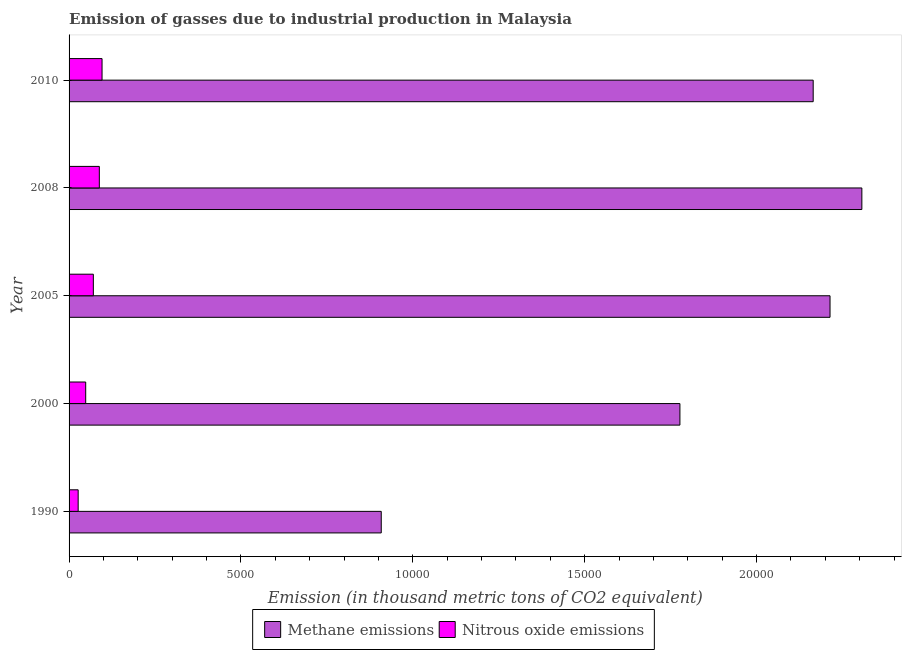How many different coloured bars are there?
Offer a terse response. 2. How many groups of bars are there?
Keep it short and to the point. 5. Are the number of bars per tick equal to the number of legend labels?
Provide a succinct answer. Yes. Are the number of bars on each tick of the Y-axis equal?
Offer a terse response. Yes. What is the label of the 2nd group of bars from the top?
Your response must be concise. 2008. In how many cases, is the number of bars for a given year not equal to the number of legend labels?
Keep it short and to the point. 0. What is the amount of methane emissions in 2000?
Give a very brief answer. 1.78e+04. Across all years, what is the maximum amount of methane emissions?
Offer a very short reply. 2.31e+04. Across all years, what is the minimum amount of nitrous oxide emissions?
Offer a terse response. 264.6. What is the total amount of nitrous oxide emissions in the graph?
Offer a terse response. 3294. What is the difference between the amount of methane emissions in 1990 and that in 2010?
Your answer should be very brief. -1.26e+04. What is the difference between the amount of methane emissions in 2005 and the amount of nitrous oxide emissions in 2010?
Make the answer very short. 2.12e+04. What is the average amount of nitrous oxide emissions per year?
Make the answer very short. 658.8. In the year 2000, what is the difference between the amount of nitrous oxide emissions and amount of methane emissions?
Keep it short and to the point. -1.73e+04. What is the ratio of the amount of nitrous oxide emissions in 2000 to that in 2010?
Your response must be concise. 0.5. Is the difference between the amount of methane emissions in 2005 and 2008 greater than the difference between the amount of nitrous oxide emissions in 2005 and 2008?
Give a very brief answer. No. What is the difference between the highest and the second highest amount of nitrous oxide emissions?
Your answer should be compact. 78.9. What is the difference between the highest and the lowest amount of methane emissions?
Your answer should be very brief. 1.40e+04. What does the 2nd bar from the top in 2008 represents?
Provide a succinct answer. Methane emissions. What does the 2nd bar from the bottom in 2000 represents?
Offer a terse response. Nitrous oxide emissions. How many bars are there?
Make the answer very short. 10. Are all the bars in the graph horizontal?
Offer a very short reply. Yes. Are the values on the major ticks of X-axis written in scientific E-notation?
Your answer should be very brief. No. Does the graph contain any zero values?
Your answer should be very brief. No. What is the title of the graph?
Make the answer very short. Emission of gasses due to industrial production in Malaysia. What is the label or title of the X-axis?
Offer a terse response. Emission (in thousand metric tons of CO2 equivalent). What is the Emission (in thousand metric tons of CO2 equivalent) in Methane emissions in 1990?
Make the answer very short. 9082.4. What is the Emission (in thousand metric tons of CO2 equivalent) in Nitrous oxide emissions in 1990?
Provide a succinct answer. 264.6. What is the Emission (in thousand metric tons of CO2 equivalent) of Methane emissions in 2000?
Provide a short and direct response. 1.78e+04. What is the Emission (in thousand metric tons of CO2 equivalent) of Nitrous oxide emissions in 2000?
Provide a short and direct response. 483.7. What is the Emission (in thousand metric tons of CO2 equivalent) of Methane emissions in 2005?
Provide a succinct answer. 2.21e+04. What is the Emission (in thousand metric tons of CO2 equivalent) in Nitrous oxide emissions in 2005?
Your response must be concise. 706. What is the Emission (in thousand metric tons of CO2 equivalent) of Methane emissions in 2008?
Offer a very short reply. 2.31e+04. What is the Emission (in thousand metric tons of CO2 equivalent) of Nitrous oxide emissions in 2008?
Your answer should be compact. 880.4. What is the Emission (in thousand metric tons of CO2 equivalent) of Methane emissions in 2010?
Give a very brief answer. 2.16e+04. What is the Emission (in thousand metric tons of CO2 equivalent) in Nitrous oxide emissions in 2010?
Your answer should be very brief. 959.3. Across all years, what is the maximum Emission (in thousand metric tons of CO2 equivalent) in Methane emissions?
Offer a very short reply. 2.31e+04. Across all years, what is the maximum Emission (in thousand metric tons of CO2 equivalent) in Nitrous oxide emissions?
Your answer should be compact. 959.3. Across all years, what is the minimum Emission (in thousand metric tons of CO2 equivalent) in Methane emissions?
Make the answer very short. 9082.4. Across all years, what is the minimum Emission (in thousand metric tons of CO2 equivalent) in Nitrous oxide emissions?
Your answer should be very brief. 264.6. What is the total Emission (in thousand metric tons of CO2 equivalent) in Methane emissions in the graph?
Keep it short and to the point. 9.37e+04. What is the total Emission (in thousand metric tons of CO2 equivalent) in Nitrous oxide emissions in the graph?
Your answer should be compact. 3294. What is the difference between the Emission (in thousand metric tons of CO2 equivalent) in Methane emissions in 1990 and that in 2000?
Give a very brief answer. -8689.1. What is the difference between the Emission (in thousand metric tons of CO2 equivalent) of Nitrous oxide emissions in 1990 and that in 2000?
Provide a succinct answer. -219.1. What is the difference between the Emission (in thousand metric tons of CO2 equivalent) of Methane emissions in 1990 and that in 2005?
Keep it short and to the point. -1.31e+04. What is the difference between the Emission (in thousand metric tons of CO2 equivalent) of Nitrous oxide emissions in 1990 and that in 2005?
Provide a succinct answer. -441.4. What is the difference between the Emission (in thousand metric tons of CO2 equivalent) in Methane emissions in 1990 and that in 2008?
Offer a very short reply. -1.40e+04. What is the difference between the Emission (in thousand metric tons of CO2 equivalent) of Nitrous oxide emissions in 1990 and that in 2008?
Your answer should be very brief. -615.8. What is the difference between the Emission (in thousand metric tons of CO2 equivalent) in Methane emissions in 1990 and that in 2010?
Your answer should be very brief. -1.26e+04. What is the difference between the Emission (in thousand metric tons of CO2 equivalent) in Nitrous oxide emissions in 1990 and that in 2010?
Make the answer very short. -694.7. What is the difference between the Emission (in thousand metric tons of CO2 equivalent) in Methane emissions in 2000 and that in 2005?
Your response must be concise. -4367.4. What is the difference between the Emission (in thousand metric tons of CO2 equivalent) in Nitrous oxide emissions in 2000 and that in 2005?
Your answer should be very brief. -222.3. What is the difference between the Emission (in thousand metric tons of CO2 equivalent) of Methane emissions in 2000 and that in 2008?
Your response must be concise. -5293.2. What is the difference between the Emission (in thousand metric tons of CO2 equivalent) of Nitrous oxide emissions in 2000 and that in 2008?
Your response must be concise. -396.7. What is the difference between the Emission (in thousand metric tons of CO2 equivalent) in Methane emissions in 2000 and that in 2010?
Keep it short and to the point. -3877.5. What is the difference between the Emission (in thousand metric tons of CO2 equivalent) of Nitrous oxide emissions in 2000 and that in 2010?
Your answer should be compact. -475.6. What is the difference between the Emission (in thousand metric tons of CO2 equivalent) in Methane emissions in 2005 and that in 2008?
Provide a succinct answer. -925.8. What is the difference between the Emission (in thousand metric tons of CO2 equivalent) in Nitrous oxide emissions in 2005 and that in 2008?
Provide a succinct answer. -174.4. What is the difference between the Emission (in thousand metric tons of CO2 equivalent) in Methane emissions in 2005 and that in 2010?
Offer a terse response. 489.9. What is the difference between the Emission (in thousand metric tons of CO2 equivalent) in Nitrous oxide emissions in 2005 and that in 2010?
Your answer should be very brief. -253.3. What is the difference between the Emission (in thousand metric tons of CO2 equivalent) of Methane emissions in 2008 and that in 2010?
Provide a short and direct response. 1415.7. What is the difference between the Emission (in thousand metric tons of CO2 equivalent) of Nitrous oxide emissions in 2008 and that in 2010?
Your response must be concise. -78.9. What is the difference between the Emission (in thousand metric tons of CO2 equivalent) of Methane emissions in 1990 and the Emission (in thousand metric tons of CO2 equivalent) of Nitrous oxide emissions in 2000?
Provide a succinct answer. 8598.7. What is the difference between the Emission (in thousand metric tons of CO2 equivalent) in Methane emissions in 1990 and the Emission (in thousand metric tons of CO2 equivalent) in Nitrous oxide emissions in 2005?
Your answer should be very brief. 8376.4. What is the difference between the Emission (in thousand metric tons of CO2 equivalent) of Methane emissions in 1990 and the Emission (in thousand metric tons of CO2 equivalent) of Nitrous oxide emissions in 2008?
Ensure brevity in your answer.  8202. What is the difference between the Emission (in thousand metric tons of CO2 equivalent) in Methane emissions in 1990 and the Emission (in thousand metric tons of CO2 equivalent) in Nitrous oxide emissions in 2010?
Provide a succinct answer. 8123.1. What is the difference between the Emission (in thousand metric tons of CO2 equivalent) in Methane emissions in 2000 and the Emission (in thousand metric tons of CO2 equivalent) in Nitrous oxide emissions in 2005?
Provide a short and direct response. 1.71e+04. What is the difference between the Emission (in thousand metric tons of CO2 equivalent) of Methane emissions in 2000 and the Emission (in thousand metric tons of CO2 equivalent) of Nitrous oxide emissions in 2008?
Your answer should be compact. 1.69e+04. What is the difference between the Emission (in thousand metric tons of CO2 equivalent) in Methane emissions in 2000 and the Emission (in thousand metric tons of CO2 equivalent) in Nitrous oxide emissions in 2010?
Give a very brief answer. 1.68e+04. What is the difference between the Emission (in thousand metric tons of CO2 equivalent) in Methane emissions in 2005 and the Emission (in thousand metric tons of CO2 equivalent) in Nitrous oxide emissions in 2008?
Your answer should be compact. 2.13e+04. What is the difference between the Emission (in thousand metric tons of CO2 equivalent) of Methane emissions in 2005 and the Emission (in thousand metric tons of CO2 equivalent) of Nitrous oxide emissions in 2010?
Ensure brevity in your answer.  2.12e+04. What is the difference between the Emission (in thousand metric tons of CO2 equivalent) of Methane emissions in 2008 and the Emission (in thousand metric tons of CO2 equivalent) of Nitrous oxide emissions in 2010?
Keep it short and to the point. 2.21e+04. What is the average Emission (in thousand metric tons of CO2 equivalent) of Methane emissions per year?
Offer a terse response. 1.87e+04. What is the average Emission (in thousand metric tons of CO2 equivalent) in Nitrous oxide emissions per year?
Ensure brevity in your answer.  658.8. In the year 1990, what is the difference between the Emission (in thousand metric tons of CO2 equivalent) of Methane emissions and Emission (in thousand metric tons of CO2 equivalent) of Nitrous oxide emissions?
Keep it short and to the point. 8817.8. In the year 2000, what is the difference between the Emission (in thousand metric tons of CO2 equivalent) in Methane emissions and Emission (in thousand metric tons of CO2 equivalent) in Nitrous oxide emissions?
Ensure brevity in your answer.  1.73e+04. In the year 2005, what is the difference between the Emission (in thousand metric tons of CO2 equivalent) in Methane emissions and Emission (in thousand metric tons of CO2 equivalent) in Nitrous oxide emissions?
Give a very brief answer. 2.14e+04. In the year 2008, what is the difference between the Emission (in thousand metric tons of CO2 equivalent) in Methane emissions and Emission (in thousand metric tons of CO2 equivalent) in Nitrous oxide emissions?
Keep it short and to the point. 2.22e+04. In the year 2010, what is the difference between the Emission (in thousand metric tons of CO2 equivalent) of Methane emissions and Emission (in thousand metric tons of CO2 equivalent) of Nitrous oxide emissions?
Your response must be concise. 2.07e+04. What is the ratio of the Emission (in thousand metric tons of CO2 equivalent) of Methane emissions in 1990 to that in 2000?
Make the answer very short. 0.51. What is the ratio of the Emission (in thousand metric tons of CO2 equivalent) of Nitrous oxide emissions in 1990 to that in 2000?
Give a very brief answer. 0.55. What is the ratio of the Emission (in thousand metric tons of CO2 equivalent) in Methane emissions in 1990 to that in 2005?
Your answer should be compact. 0.41. What is the ratio of the Emission (in thousand metric tons of CO2 equivalent) in Nitrous oxide emissions in 1990 to that in 2005?
Give a very brief answer. 0.37. What is the ratio of the Emission (in thousand metric tons of CO2 equivalent) of Methane emissions in 1990 to that in 2008?
Offer a terse response. 0.39. What is the ratio of the Emission (in thousand metric tons of CO2 equivalent) of Nitrous oxide emissions in 1990 to that in 2008?
Make the answer very short. 0.3. What is the ratio of the Emission (in thousand metric tons of CO2 equivalent) of Methane emissions in 1990 to that in 2010?
Ensure brevity in your answer.  0.42. What is the ratio of the Emission (in thousand metric tons of CO2 equivalent) in Nitrous oxide emissions in 1990 to that in 2010?
Provide a succinct answer. 0.28. What is the ratio of the Emission (in thousand metric tons of CO2 equivalent) of Methane emissions in 2000 to that in 2005?
Offer a terse response. 0.8. What is the ratio of the Emission (in thousand metric tons of CO2 equivalent) in Nitrous oxide emissions in 2000 to that in 2005?
Keep it short and to the point. 0.69. What is the ratio of the Emission (in thousand metric tons of CO2 equivalent) of Methane emissions in 2000 to that in 2008?
Make the answer very short. 0.77. What is the ratio of the Emission (in thousand metric tons of CO2 equivalent) of Nitrous oxide emissions in 2000 to that in 2008?
Ensure brevity in your answer.  0.55. What is the ratio of the Emission (in thousand metric tons of CO2 equivalent) of Methane emissions in 2000 to that in 2010?
Your response must be concise. 0.82. What is the ratio of the Emission (in thousand metric tons of CO2 equivalent) of Nitrous oxide emissions in 2000 to that in 2010?
Your answer should be very brief. 0.5. What is the ratio of the Emission (in thousand metric tons of CO2 equivalent) of Methane emissions in 2005 to that in 2008?
Ensure brevity in your answer.  0.96. What is the ratio of the Emission (in thousand metric tons of CO2 equivalent) of Nitrous oxide emissions in 2005 to that in 2008?
Offer a very short reply. 0.8. What is the ratio of the Emission (in thousand metric tons of CO2 equivalent) in Methane emissions in 2005 to that in 2010?
Your response must be concise. 1.02. What is the ratio of the Emission (in thousand metric tons of CO2 equivalent) in Nitrous oxide emissions in 2005 to that in 2010?
Ensure brevity in your answer.  0.74. What is the ratio of the Emission (in thousand metric tons of CO2 equivalent) in Methane emissions in 2008 to that in 2010?
Provide a short and direct response. 1.07. What is the ratio of the Emission (in thousand metric tons of CO2 equivalent) in Nitrous oxide emissions in 2008 to that in 2010?
Offer a very short reply. 0.92. What is the difference between the highest and the second highest Emission (in thousand metric tons of CO2 equivalent) in Methane emissions?
Ensure brevity in your answer.  925.8. What is the difference between the highest and the second highest Emission (in thousand metric tons of CO2 equivalent) of Nitrous oxide emissions?
Keep it short and to the point. 78.9. What is the difference between the highest and the lowest Emission (in thousand metric tons of CO2 equivalent) in Methane emissions?
Provide a short and direct response. 1.40e+04. What is the difference between the highest and the lowest Emission (in thousand metric tons of CO2 equivalent) of Nitrous oxide emissions?
Ensure brevity in your answer.  694.7. 